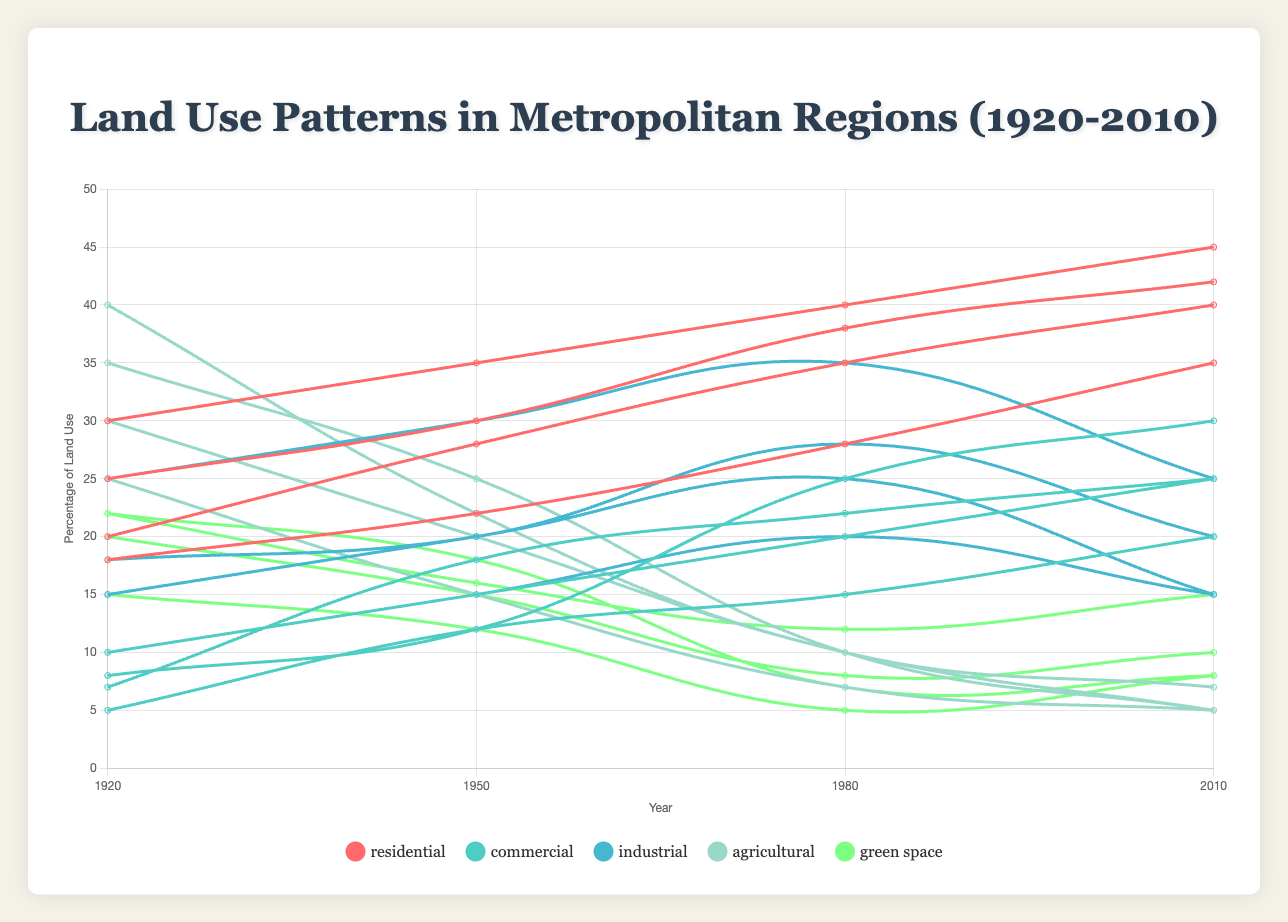What is the trend in the percentage of residential land use in New York City from 1920 to 2010? The chart shows that the percentage of residential land use in New York City increased steadily over the years. In 1920, it was 30%, which increased to 35% in 1950, 40% in 1980, and reached 45% in 2010.
Answer: An increasing trend Which region had the highest percentage of residential land use in 2010? To find the region with the highest percentage of residential land use in 2010, look at the lines representing 2010 for all regions. The data shows that New York City had 45%, Los Angeles had 42%, Chicago had 40%, and Houston had 35%. Thus, New York City had the highest percentage.
Answer: New York City What is the difference in the percentage of agricultural land use between 1920 and 2010 in Chicago? In 1920, the chart shows that Chicago had 40% agricultural land use, and in 2010, it had 7%. Subtract the 2010 value from the 1920 value: 40% - 7% = 33%.
Answer: 33% Comparing 1950 and 2010, which region saw the largest decrease in green space? For each region, calculate the decrease in green space. New York City decreased from 15% to 10% (5% decrease), Los Angeles from 18% to 8% (10% decrease), Chicago from 12% to 8% (4% decrease), and Houston from 16% to 15% (1% decrease). The region with the largest decrease is Los Angeles with 10%.
Answer: Los Angeles What was the most significant change in commercial land use in any region between 1920 and 2010? Compare the change in commercial land use for each region between 1920 and 2010. New York City increased from 10% to 25% (15% change), Los Angeles from 8% to 30% (22% change), Chicago from 7% to 25% (18% change), and Houston from 5% to 20% (15% change). The largest change was in Los Angeles with a 22% increase.
Answer: 22% in Los Angeles By how much did the percentage of industrial land use change in Houston from 1920 to 1980? In 1920, Houston had 25% industrial land use, which increased to 35% in 1980. The change is calculated as 35% - 25% = 10%.
Answer: 10% What is the average percentage of green space in all regions in 2010? Sum the green space percentages in 2010 for all regions then divide by the number of regions: (10 + 8 + 8 + 15) / 4 = 41 / 4 = 10.25%.
Answer: 10.25% Comparing the trends in agricultural land use in New York City and Los Angeles, which city saw a greater reduction between 1920 and 2010? In New York City, agricultural land use decreased from 25% in 1920 to 5% in 2010, a reduction of 20%. In Los Angeles, it decreased from 35% to 5%, a reduction of 30%. Los Angeles saw a greater reduction.
Answer: Los Angeles Among the regions shown, which had the least industrial land use in 1950? Look at the industrial land use data for 1950 in each region: New York City had 20%, Los Angeles had 15%, Chicago had 20%, and Houston had 30%. Los Angeles had the least industrial land use.
Answer: Los Angeles How much did the percentage of commercial land use increase in Los Angeles from 1950 to 2010? In 1950, Los Angeles had 12% commercial land use, which increased to 30% in 2010. The increase is calculated as 30% - 12% = 18%.
Answer: 18% 